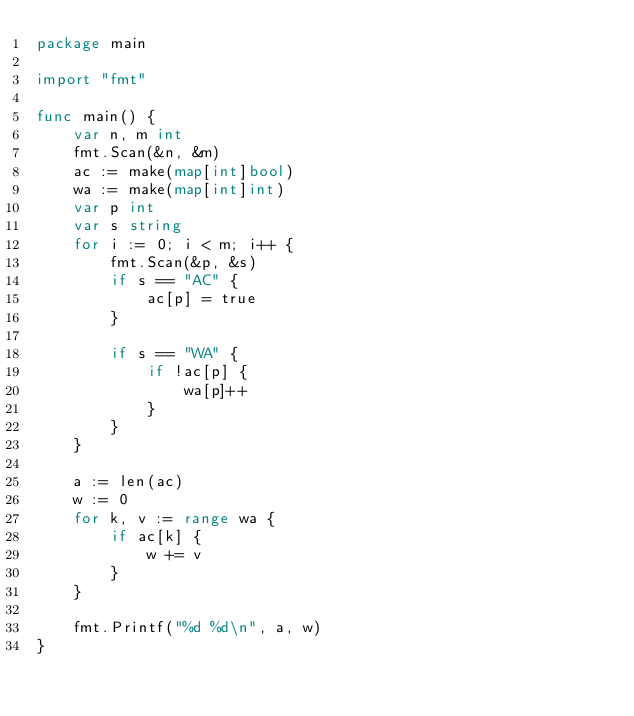Convert code to text. <code><loc_0><loc_0><loc_500><loc_500><_Go_>package main

import "fmt"

func main() {
	var n, m int
	fmt.Scan(&n, &m)
	ac := make(map[int]bool)
	wa := make(map[int]int)
	var p int
	var s string
	for i := 0; i < m; i++ {
		fmt.Scan(&p, &s)
		if s == "AC" {
			ac[p] = true
		}

		if s == "WA" {
			if !ac[p] {
				wa[p]++
			}
		}
	}

	a := len(ac)
	w := 0
	for k, v := range wa {
		if ac[k] {
			w += v
		}
	}

	fmt.Printf("%d %d\n", a, w)
}
</code> 